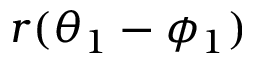Convert formula to latex. <formula><loc_0><loc_0><loc_500><loc_500>r ( \theta _ { 1 } - \phi _ { 1 } )</formula> 